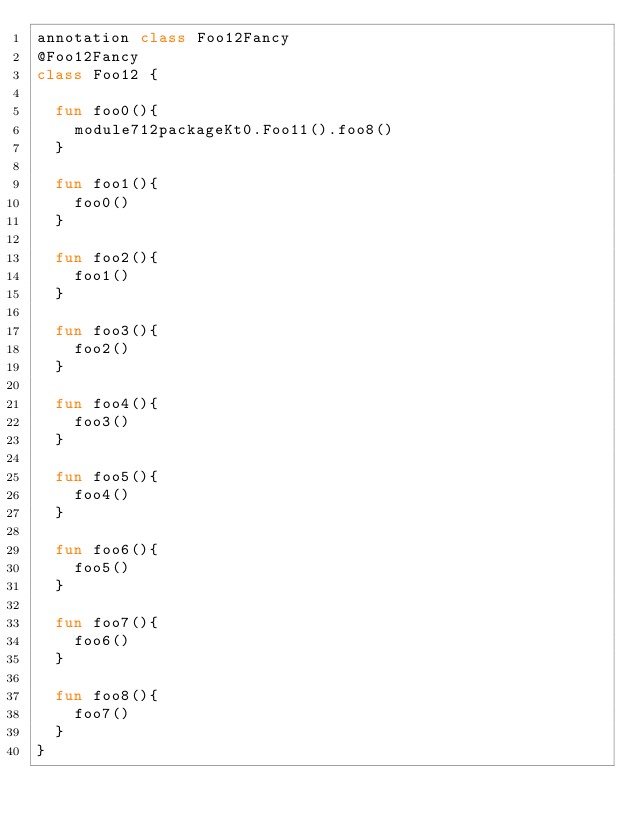Convert code to text. <code><loc_0><loc_0><loc_500><loc_500><_Kotlin_>annotation class Foo12Fancy
@Foo12Fancy
class Foo12 {

  fun foo0(){
    module712packageKt0.Foo11().foo8()
  }

  fun foo1(){
    foo0()
  }

  fun foo2(){
    foo1()
  }

  fun foo3(){
    foo2()
  }

  fun foo4(){
    foo3()
  }

  fun foo5(){
    foo4()
  }

  fun foo6(){
    foo5()
  }

  fun foo7(){
    foo6()
  }

  fun foo8(){
    foo7()
  }
}</code> 